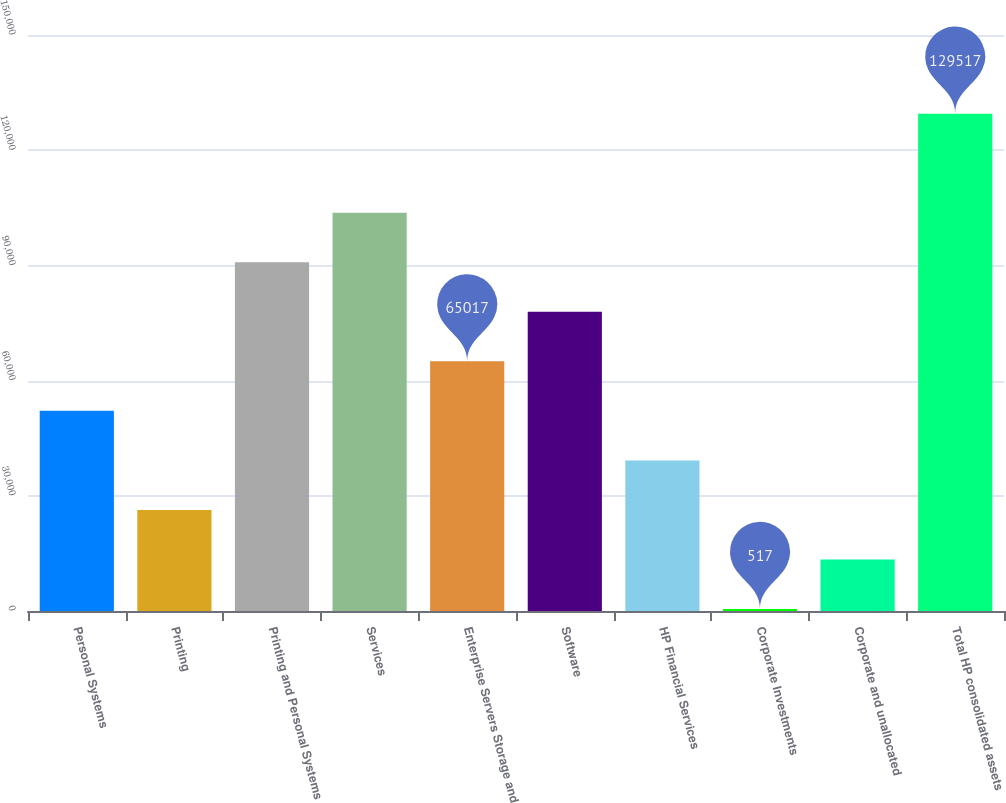Convert chart to OTSL. <chart><loc_0><loc_0><loc_500><loc_500><bar_chart><fcel>Personal Systems<fcel>Printing<fcel>Printing and Personal Systems<fcel>Services<fcel>Enterprise Servers Storage and<fcel>Software<fcel>HP Financial Services<fcel>Corporate Investments<fcel>Corporate and unallocated<fcel>Total HP consolidated assets<nl><fcel>52117<fcel>26317<fcel>90817<fcel>103717<fcel>65017<fcel>77917<fcel>39217<fcel>517<fcel>13417<fcel>129517<nl></chart> 